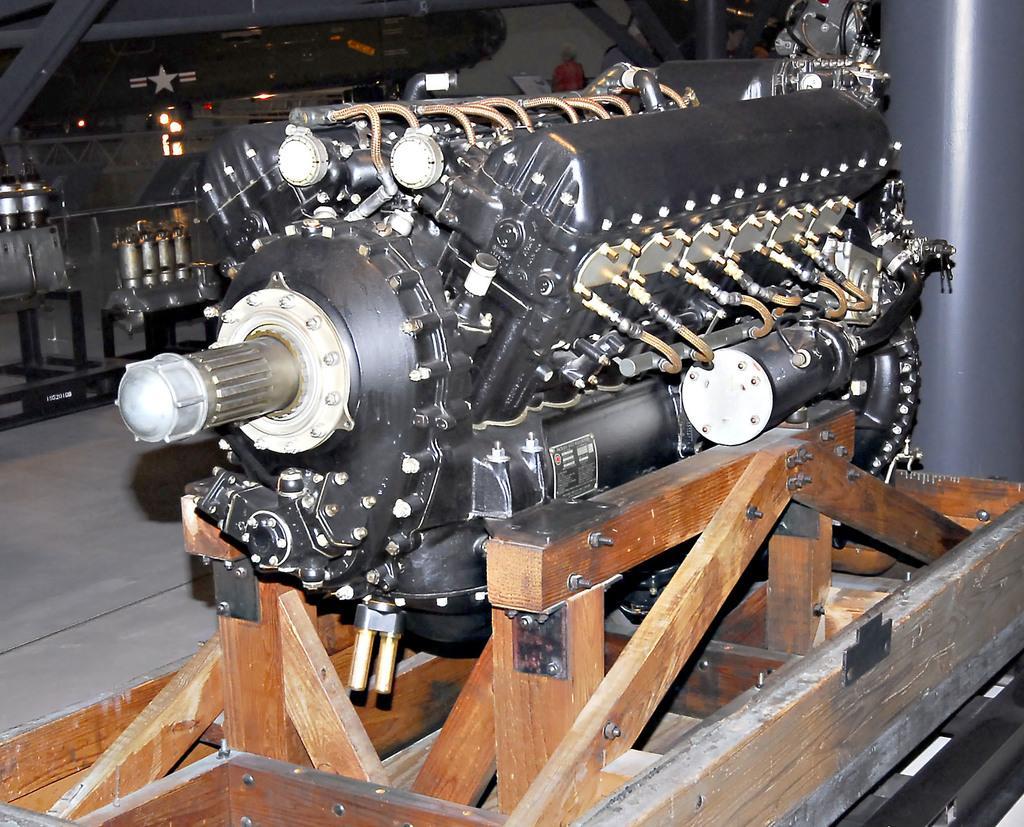Describe this image in one or two sentences. In this image, we can see an engine kept on the wooden block, in the background we can see some metal objects. 